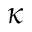<formula> <loc_0><loc_0><loc_500><loc_500>\kappa</formula> 